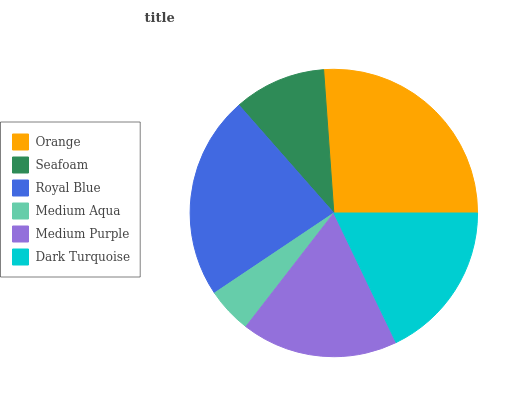Is Medium Aqua the minimum?
Answer yes or no. Yes. Is Orange the maximum?
Answer yes or no. Yes. Is Seafoam the minimum?
Answer yes or no. No. Is Seafoam the maximum?
Answer yes or no. No. Is Orange greater than Seafoam?
Answer yes or no. Yes. Is Seafoam less than Orange?
Answer yes or no. Yes. Is Seafoam greater than Orange?
Answer yes or no. No. Is Orange less than Seafoam?
Answer yes or no. No. Is Dark Turquoise the high median?
Answer yes or no. Yes. Is Medium Purple the low median?
Answer yes or no. Yes. Is Medium Aqua the high median?
Answer yes or no. No. Is Dark Turquoise the low median?
Answer yes or no. No. 